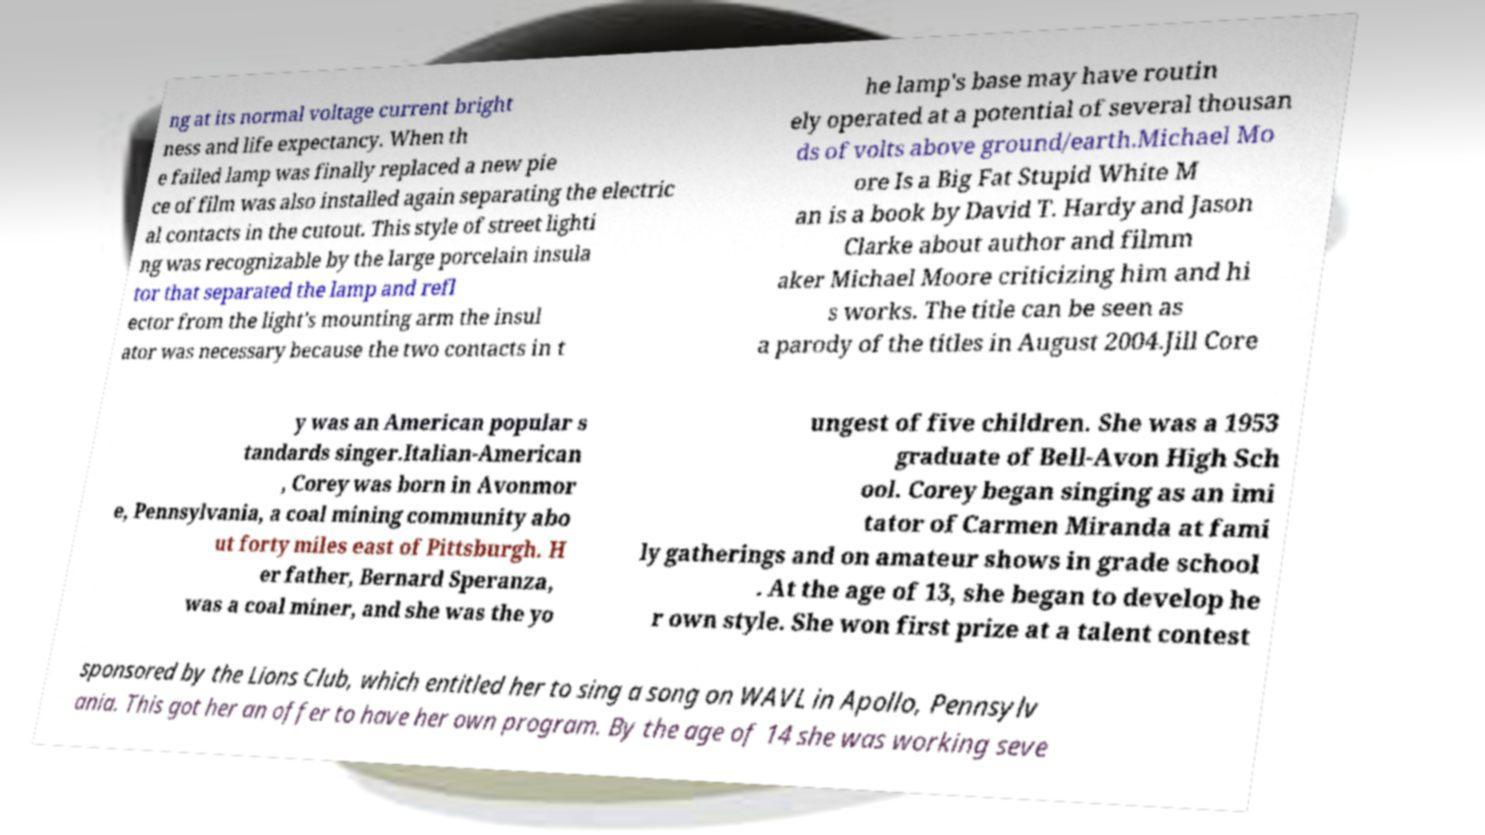Can you accurately transcribe the text from the provided image for me? ng at its normal voltage current bright ness and life expectancy. When th e failed lamp was finally replaced a new pie ce of film was also installed again separating the electric al contacts in the cutout. This style of street lighti ng was recognizable by the large porcelain insula tor that separated the lamp and refl ector from the light's mounting arm the insul ator was necessary because the two contacts in t he lamp's base may have routin ely operated at a potential of several thousan ds of volts above ground/earth.Michael Mo ore Is a Big Fat Stupid White M an is a book by David T. Hardy and Jason Clarke about author and filmm aker Michael Moore criticizing him and hi s works. The title can be seen as a parody of the titles in August 2004.Jill Core y was an American popular s tandards singer.Italian-American , Corey was born in Avonmor e, Pennsylvania, a coal mining community abo ut forty miles east of Pittsburgh. H er father, Bernard Speranza, was a coal miner, and she was the yo ungest of five children. She was a 1953 graduate of Bell-Avon High Sch ool. Corey began singing as an imi tator of Carmen Miranda at fami ly gatherings and on amateur shows in grade school . At the age of 13, she began to develop he r own style. She won first prize at a talent contest sponsored by the Lions Club, which entitled her to sing a song on WAVL in Apollo, Pennsylv ania. This got her an offer to have her own program. By the age of 14 she was working seve 